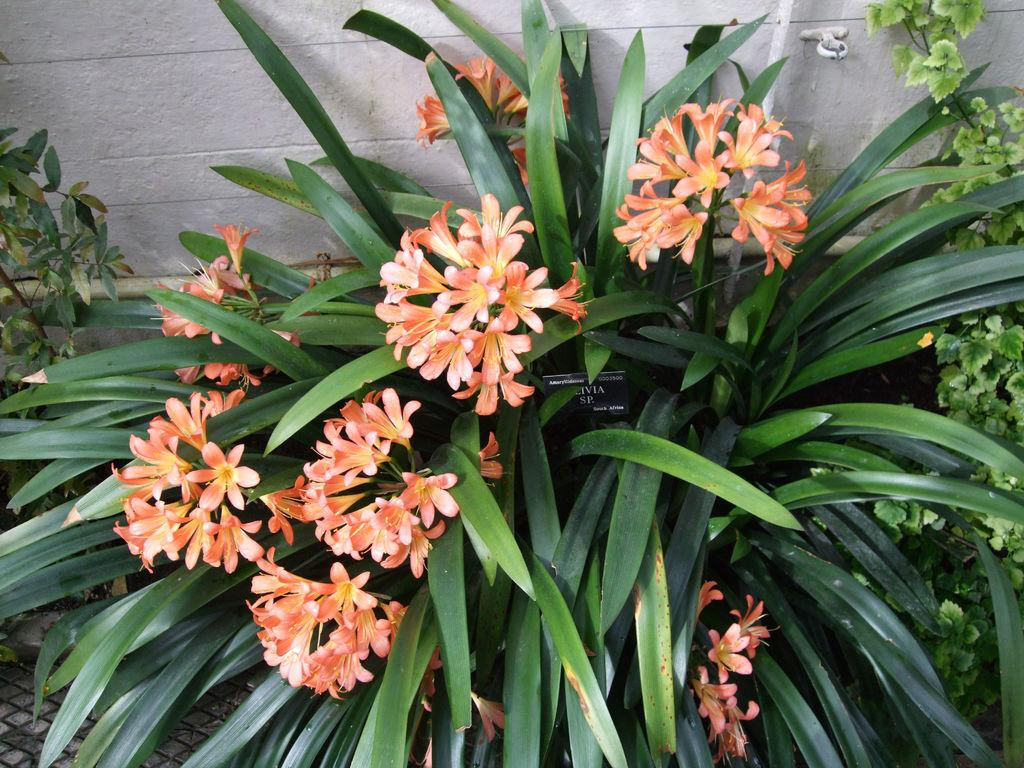What type of living organisms can be seen in the image? Plants and flowers can be seen in the image. Can you describe the background of the image? There is a wall visible in the background of the image. Is your sister stuck in the quicksand in the image? There is no quicksand or sister present in the image. What is the digestive system of the flowers in the image? Flowers do not have a digestive system, as they are plants and not animals. 